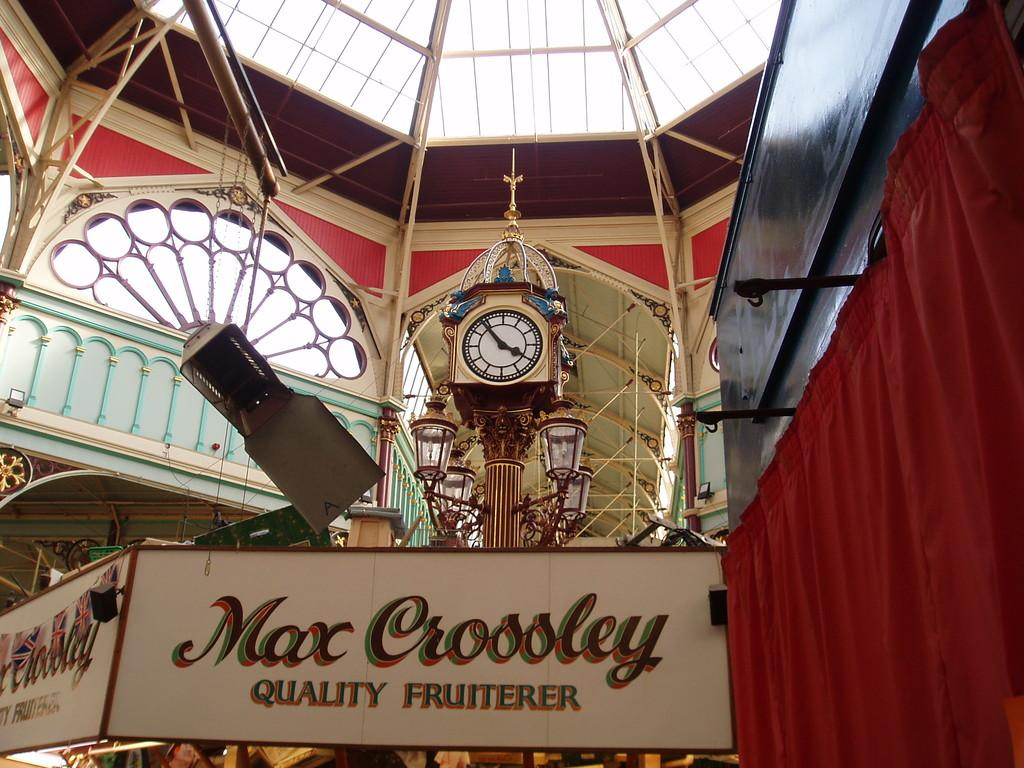Provide a one-sentence caption for the provided image. a building with a clock in the center store is called max crossley. 